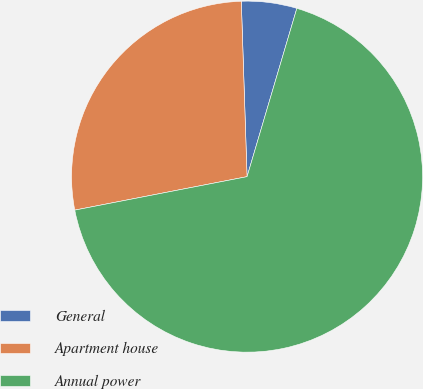<chart> <loc_0><loc_0><loc_500><loc_500><pie_chart><fcel>General<fcel>Apartment house<fcel>Annual power<nl><fcel>5.1%<fcel>27.53%<fcel>67.37%<nl></chart> 